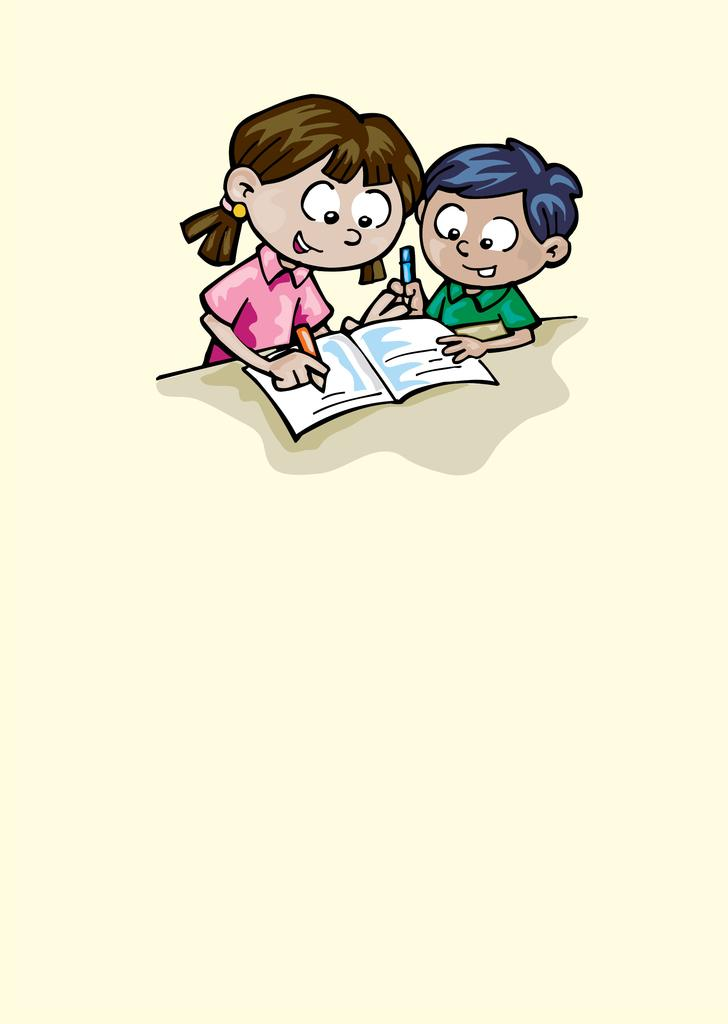What type of image is being described? The image is a cartoon. Who are the characters in the image? There is a boy and a girl in the image. What is the boy holding in the image? The boy is holding a pencil. What is the boy looking at in the image? The boy is looking at a book. What is the girl holding in the image? The girl is holding a pencil. What is the girl doing in the image? The girl is writing in a book. What type of food is the boy eating in the image? There is no food present in the image; the boy is holding a pencil and looking at a book. What type of spy equipment is the girl using in the image? There is no spy equipment present in the image; the girl is holding a pencil and writing in a book. 